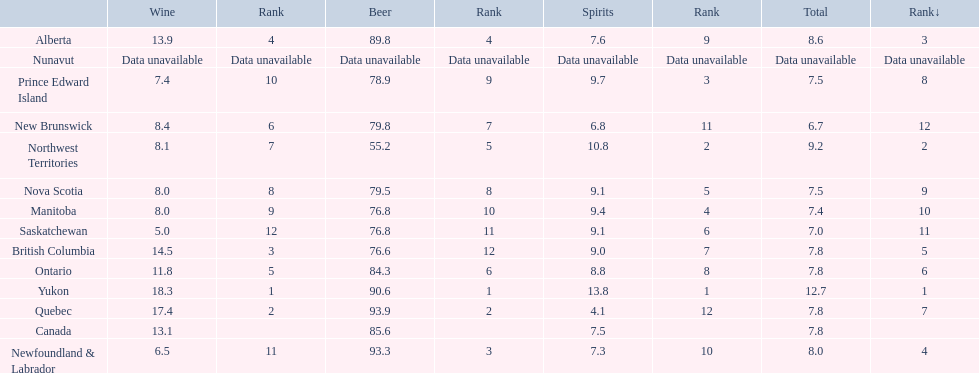Which canadian territory had a beer consumption of 93.9? Quebec. What was their consumption of spirits? 4.1. 